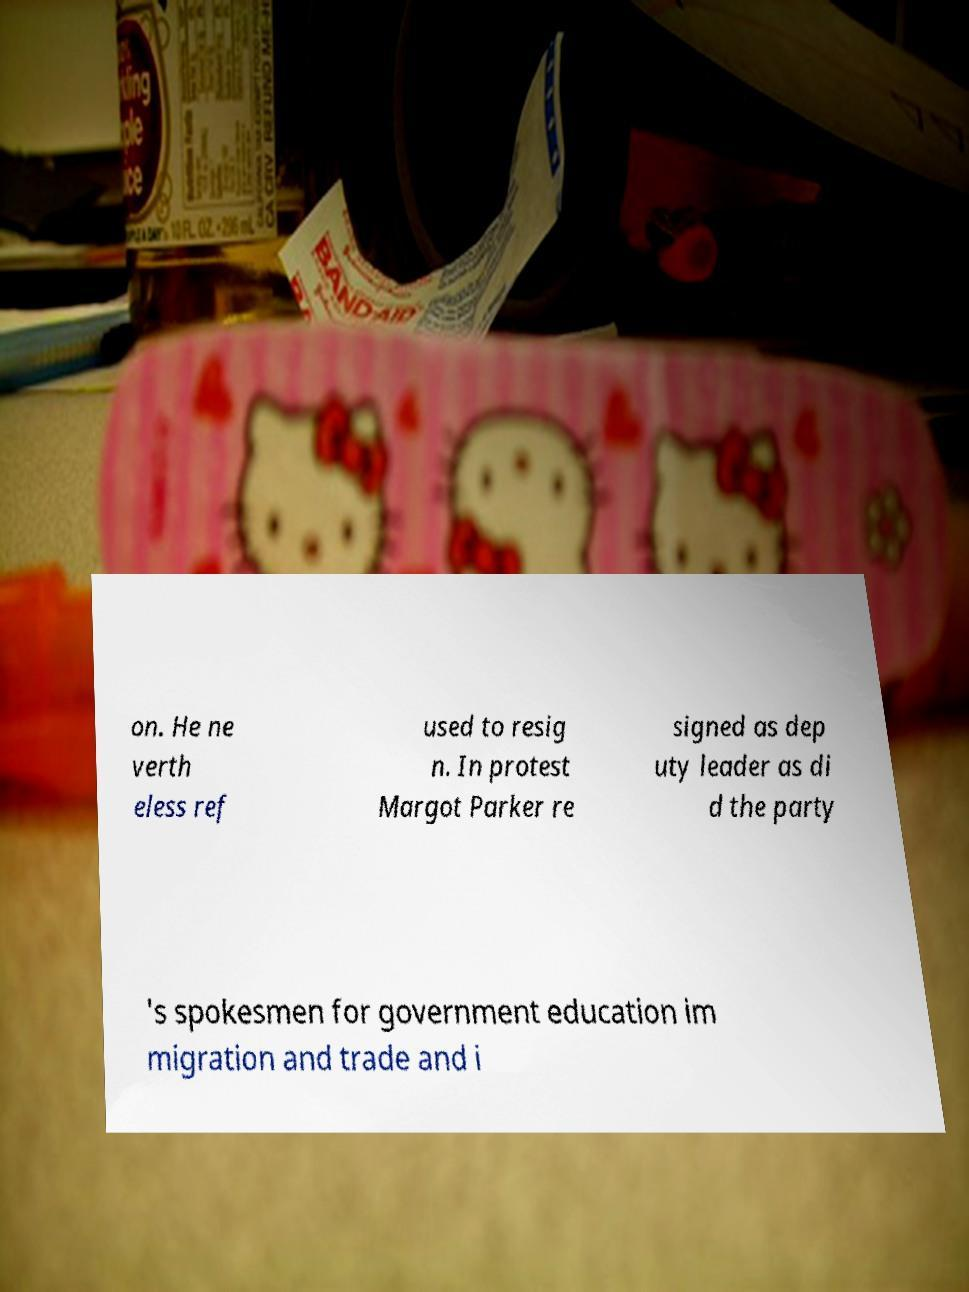There's text embedded in this image that I need extracted. Can you transcribe it verbatim? on. He ne verth eless ref used to resig n. In protest Margot Parker re signed as dep uty leader as di d the party 's spokesmen for government education im migration and trade and i 